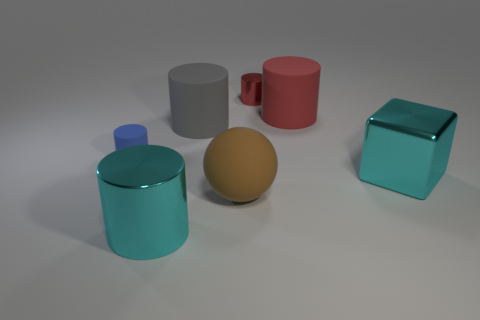Are there the same number of large rubber objects on the right side of the large gray cylinder and metallic cylinders?
Provide a succinct answer. Yes. What number of tiny cylinders are made of the same material as the cyan block?
Your answer should be compact. 1. Is the number of blue metallic blocks less than the number of cyan shiny cubes?
Provide a short and direct response. Yes. Do the tiny cylinder behind the red matte cylinder and the large shiny cylinder have the same color?
Ensure brevity in your answer.  No. There is a large shiny object that is behind the big cylinder in front of the small blue matte object; what number of large shiny cubes are right of it?
Offer a very short reply. 0. There is a large metal cylinder; how many large gray things are behind it?
Your answer should be compact. 1. What is the color of the other big shiny object that is the same shape as the red metal thing?
Provide a succinct answer. Cyan. There is a object that is to the left of the large gray rubber cylinder and in front of the cube; what is it made of?
Provide a succinct answer. Metal. There is a metal cylinder that is behind the cyan cylinder; does it have the same size as the blue rubber cylinder?
Offer a very short reply. Yes. What is the material of the big cyan block?
Your response must be concise. Metal. 